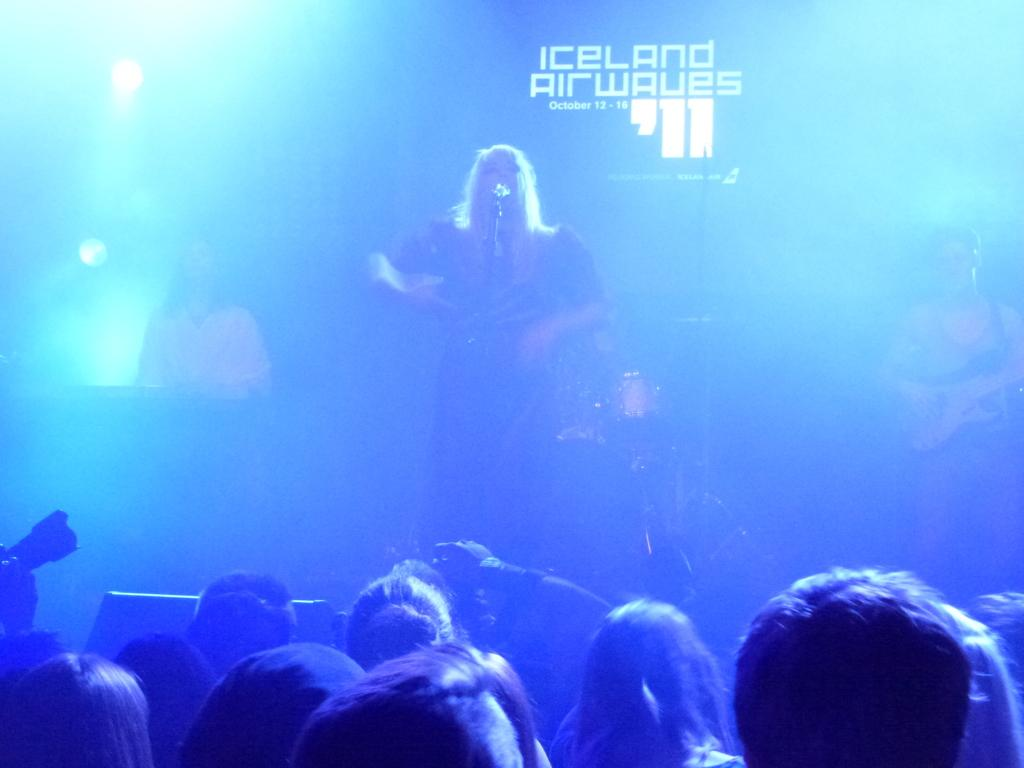What is the woman in the image doing? The woman is singing in the image. What is the woman holding while singing? There is a microphone in the image. Are there any other people present in the image? Yes, there are people visible in the image. What color lines are present on the left side of the image? There are blue color lines on the left side of the image. What type of thread is being used to create the fire in the image? There is no thread or fire present in the image; it features a woman singing with a microphone and people around her, along with blue color lines on the left side. 